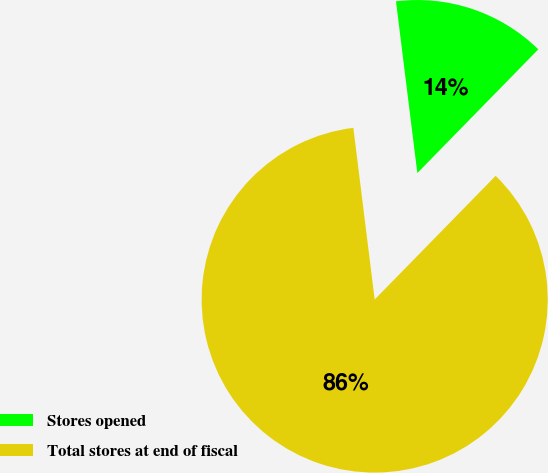Convert chart to OTSL. <chart><loc_0><loc_0><loc_500><loc_500><pie_chart><fcel>Stores opened<fcel>Total stores at end of fiscal<nl><fcel>14.29%<fcel>85.71%<nl></chart> 